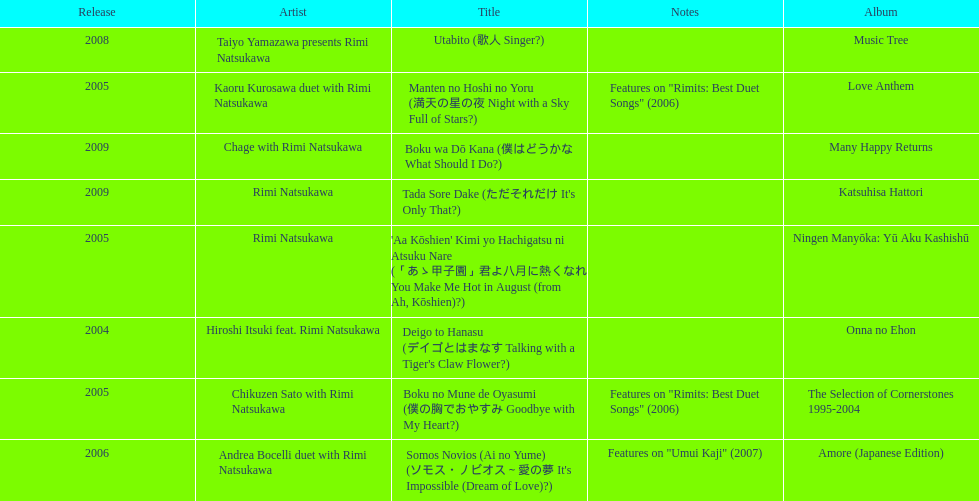Write the full table. {'header': ['Release', 'Artist', 'Title', 'Notes', 'Album'], 'rows': [['2008', 'Taiyo Yamazawa presents Rimi Natsukawa', 'Utabito (歌人 Singer?)', '', 'Music Tree'], ['2005', 'Kaoru Kurosawa duet with Rimi Natsukawa', 'Manten no Hoshi no Yoru (満天の星の夜 Night with a Sky Full of Stars?)', 'Features on "Rimits: Best Duet Songs" (2006)', 'Love Anthem'], ['2009', 'Chage with Rimi Natsukawa', 'Boku wa Dō Kana (僕はどうかな What Should I Do?)', '', 'Many Happy Returns'], ['2009', 'Rimi Natsukawa', "Tada Sore Dake (ただそれだけ It's Only That?)", '', 'Katsuhisa Hattori'], ['2005', 'Rimi Natsukawa', "'Aa Kōshien' Kimi yo Hachigatsu ni Atsuku Nare (「あゝ甲子園」君よ八月に熱くなれ You Make Me Hot in August (from Ah, Kōshien)?)", '', 'Ningen Manyōka: Yū Aku Kashishū'], ['2004', 'Hiroshi Itsuki feat. Rimi Natsukawa', "Deigo to Hanasu (デイゴとはまなす Talking with a Tiger's Claw Flower?)", '', 'Onna no Ehon'], ['2005', 'Chikuzen Sato with Rimi Natsukawa', 'Boku no Mune de Oyasumi (僕の胸でおやすみ Goodbye with My Heart?)', 'Features on "Rimits: Best Duet Songs" (2006)', 'The Selection of Cornerstones 1995-2004'], ['2006', 'Andrea Bocelli duet with Rimi Natsukawa', "Somos Novios (Ai no Yume) (ソモス・ノビオス～愛の夢 It's Impossible (Dream of Love)?)", 'Features on "Umui Kaji" (2007)', 'Amore (Japanese Edition)']]} Which title has the same notes as night with a sky full of stars? Boku no Mune de Oyasumi (僕の胸でおやすみ Goodbye with My Heart?). 